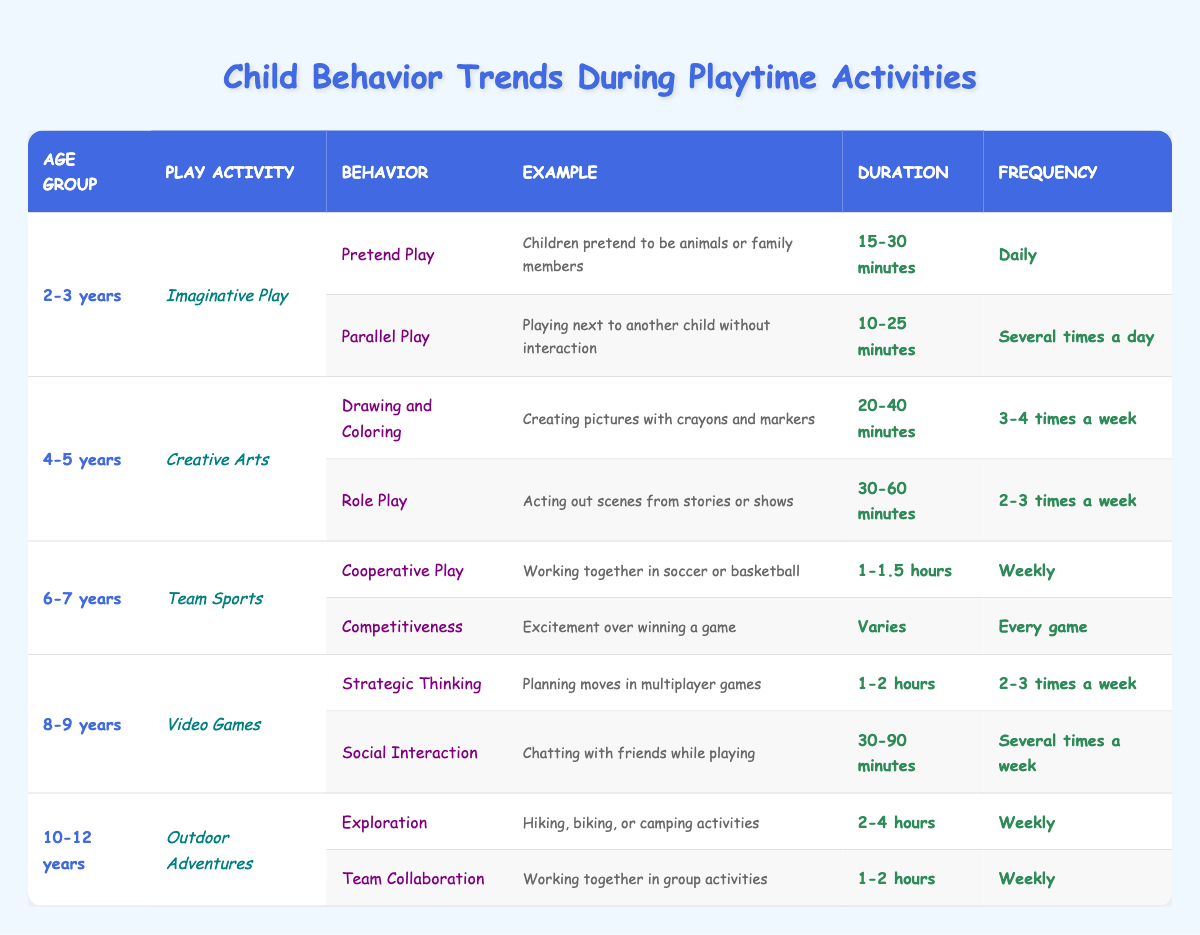What is the play activity for children aged 4-5 years? Looking at the table, it states that the play activity for children in the 4-5 years age group is "Creative Arts."
Answer: Creative Arts How often do children aged 2-3 years engage in pretend play? Referring to the table, it shows that children aged 2-3 years engage in pretend play daily.
Answer: Daily What is the duration of competitive play for children aged 6-7 years? The table specifies that the duration of competitive play for this age group is variable, indicating it can change from one game to another.
Answer: Varies Which age group participates in outdoor adventures weekly? By reviewing the table, we can see that children aged 10-12 years participate in outdoor adventures weekly.
Answer: 10-12 years What is the average duration of strategic thinking activities for children aged 8-9 years? From the data, children aged 8-9 years spend between 1-2 hours on strategic thinking activities. Thus, averaging these gives us (1 + 2) / 2 = 1.5 hours.
Answer: 1.5 hours Is it true that children aged 4-5 years have role play as a frequent activity? Yes, according to the table, role play happens 2-3 times a week within the 4-5 years age group, which qualifies as a frequent activity.
Answer: Yes Compare the engagement duration for imaginative play and creative arts. Which one has a longer duration? The table states that the duration for imaginative play for 2-3 years is 15-30 minutes and for creative arts for 4-5 years is 20-40 minutes. Since 20 minutes is higher than 15, and 40 is higher than 30, creative arts has a longer duration overall.
Answer: Creative arts How many times a week do children aged 8-9 years typically interact socially while playing video games? The table indicates that social interaction usually occurs several times a week for this age group while playing video games.
Answer: Several times a week Do children aged 10-12 years participate in team collaboration less than weekly? No, the data shows that team collaboration occurs weekly for the 10-12 years age group, meaning they do not participate less than weekly.
Answer: No 